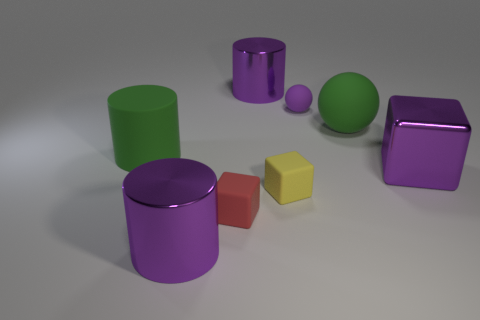Add 1 yellow rubber things. How many objects exist? 9 Subtract all cylinders. How many objects are left? 5 Add 8 red rubber blocks. How many red rubber blocks are left? 9 Add 8 large matte cylinders. How many large matte cylinders exist? 9 Subtract 0 gray blocks. How many objects are left? 8 Subtract all tiny red things. Subtract all red blocks. How many objects are left? 6 